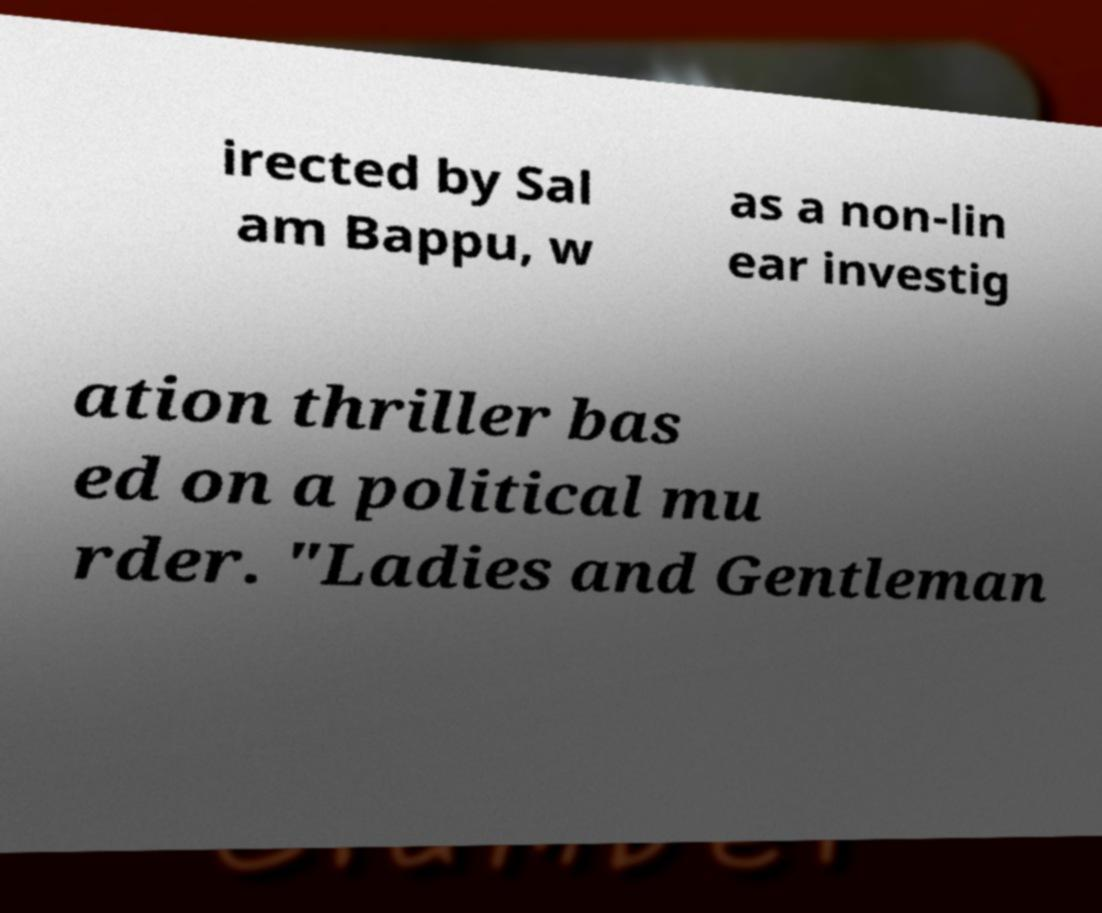Please read and relay the text visible in this image. What does it say? irected by Sal am Bappu, w as a non-lin ear investig ation thriller bas ed on a political mu rder. "Ladies and Gentleman 